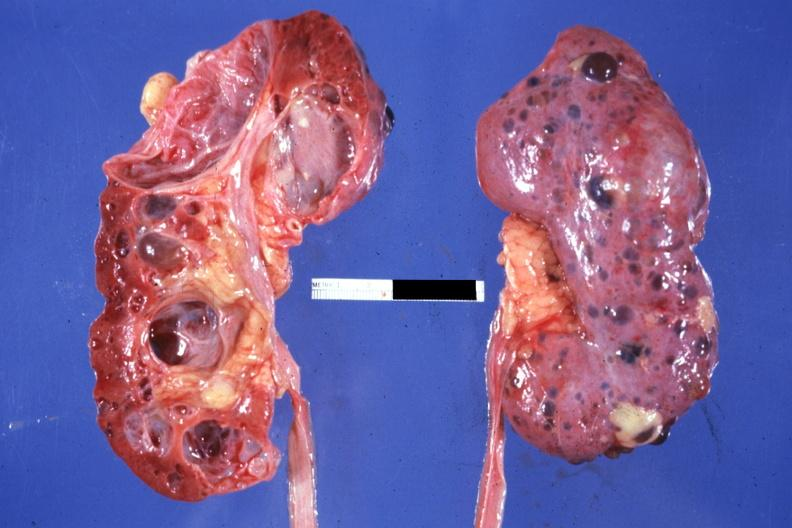how much kidney opened the other from capsular surface many cysts?
Answer the question using a single word or phrase. One 